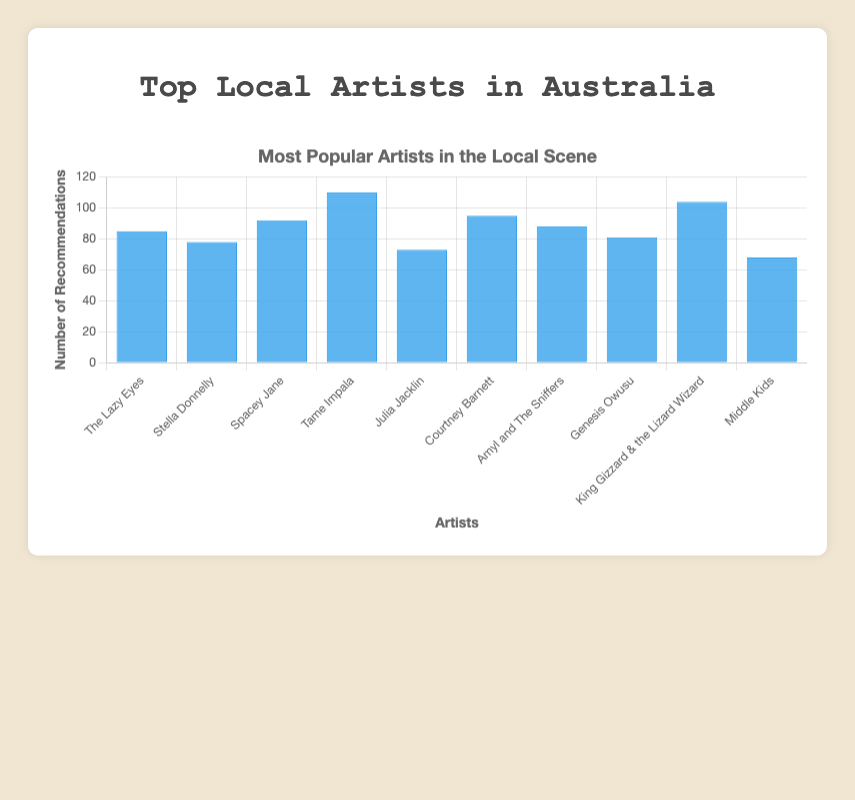Which artist has the most recommendations? The artist with the highest bar has the most recommendations. The tallest bar belongs to Tame Impala.
Answer: Tame Impala Which artist has the second highest number of recommendations? The second tallest bar indicates the artist with the second highest recommendations. The second tallest bar belongs to King Gizzard & the Lizard Wizard.
Answer: King Gizzard & the Lizard Wizard Who has more recommendations, Courtney Barnett or Spacey Jane? Look at the heights of the bars for both artists. Courtney Barnett's bar is taller than Spacey Jane's bar.
Answer: Courtney Barnett What is the total number of recommendations for the top three artists? Add the recommendations of Tame Impala (110), King Gizzard & the Lizard Wizard (104), and Courtney Barnett (95). 110 + 104 + 95 = 309
Answer: 309 How many more recommendations does Tame Impala have compared to Middle Kids? Subtract Middle Kids' recommendations (68) from Tame Impala's recommendations (110). 110 - 68 = 42
Answer: 42 What is the average number of recommendations across all artists? Sum all recommendations and divide by the number of artists: (85 + 78 + 92 + 110 + 73 + 95 + 88 + 81 + 104 + 68) / 10 = 876 / 10 = 87.6
Answer: 87.6 Compare the recommendations of Amyl and The Sniffers and Julia Jacklin. Who has more and by how much? Subtract Julia Jacklin's recommendations (73) from Amyl and The Sniffers' recommendations (88). 88 - 73 = 15
Answer: Amyl and The Sniffers, 15 more What is the median number of recommendations? Arrange the recommendations in ascending order and find the middle value. The list is [68, 73, 78, 81, 85, 88, 92, 95, 104, 110]. The median is the average of the 5th and 6th values (85 and 88): (85 + 88) / 2 = 86.5
Answer: 86.5 Which artist has the fewest recommendations? The artist with the shortest bar has the fewest recommendations. The shortest bar belongs to Middle Kids.
Answer: Middle Kids 